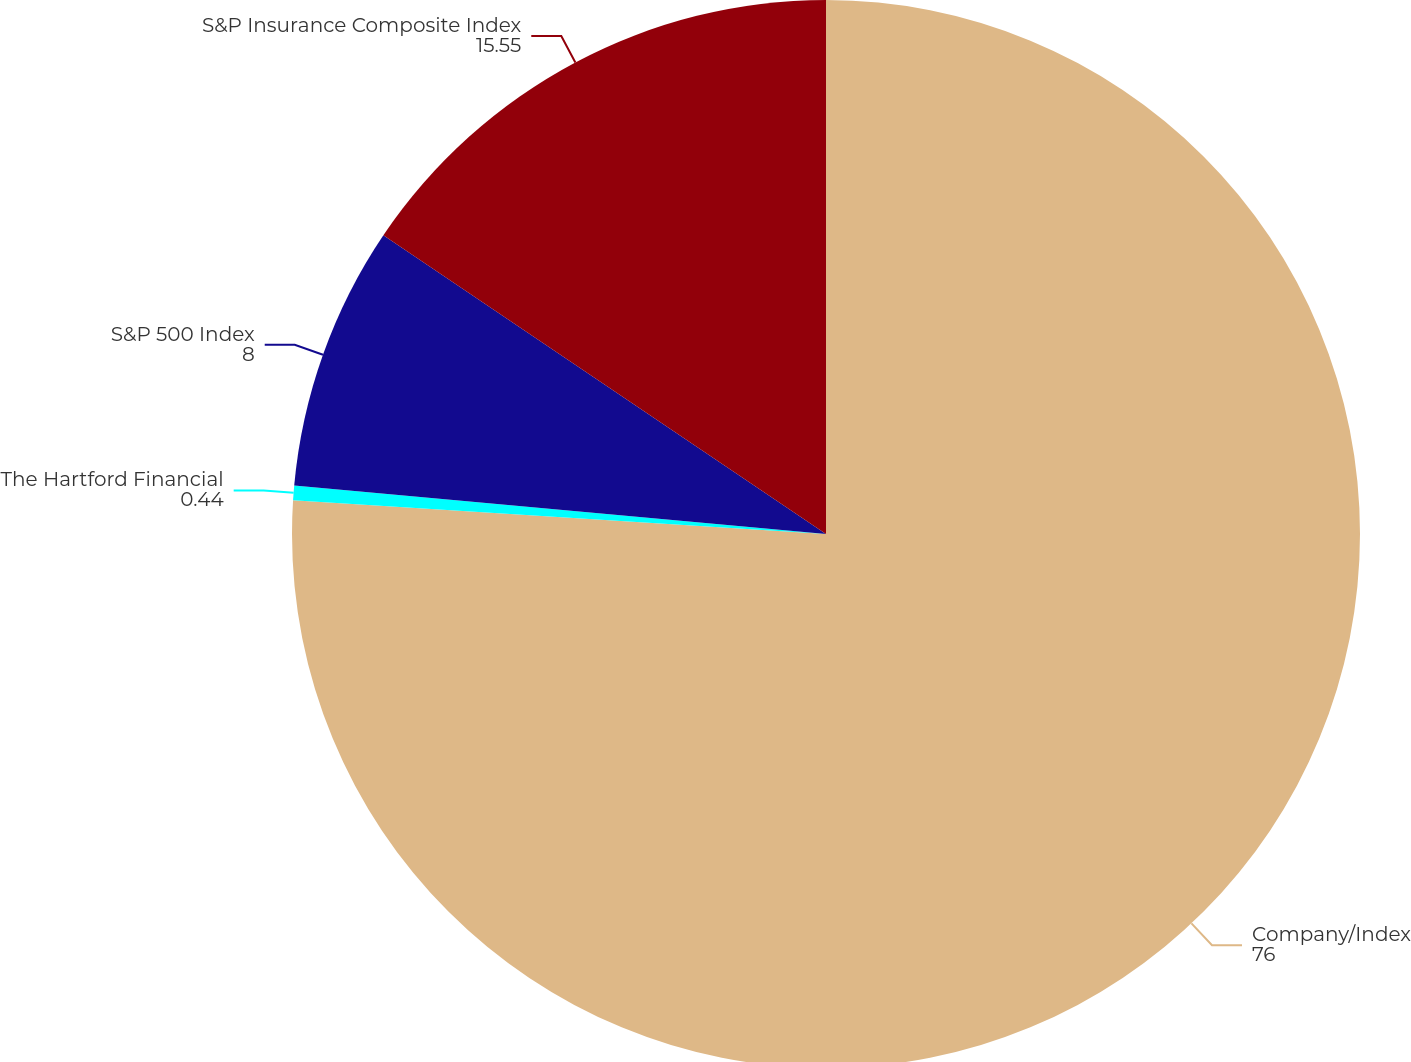Convert chart to OTSL. <chart><loc_0><loc_0><loc_500><loc_500><pie_chart><fcel>Company/Index<fcel>The Hartford Financial<fcel>S&P 500 Index<fcel>S&P Insurance Composite Index<nl><fcel>76.0%<fcel>0.44%<fcel>8.0%<fcel>15.55%<nl></chart> 